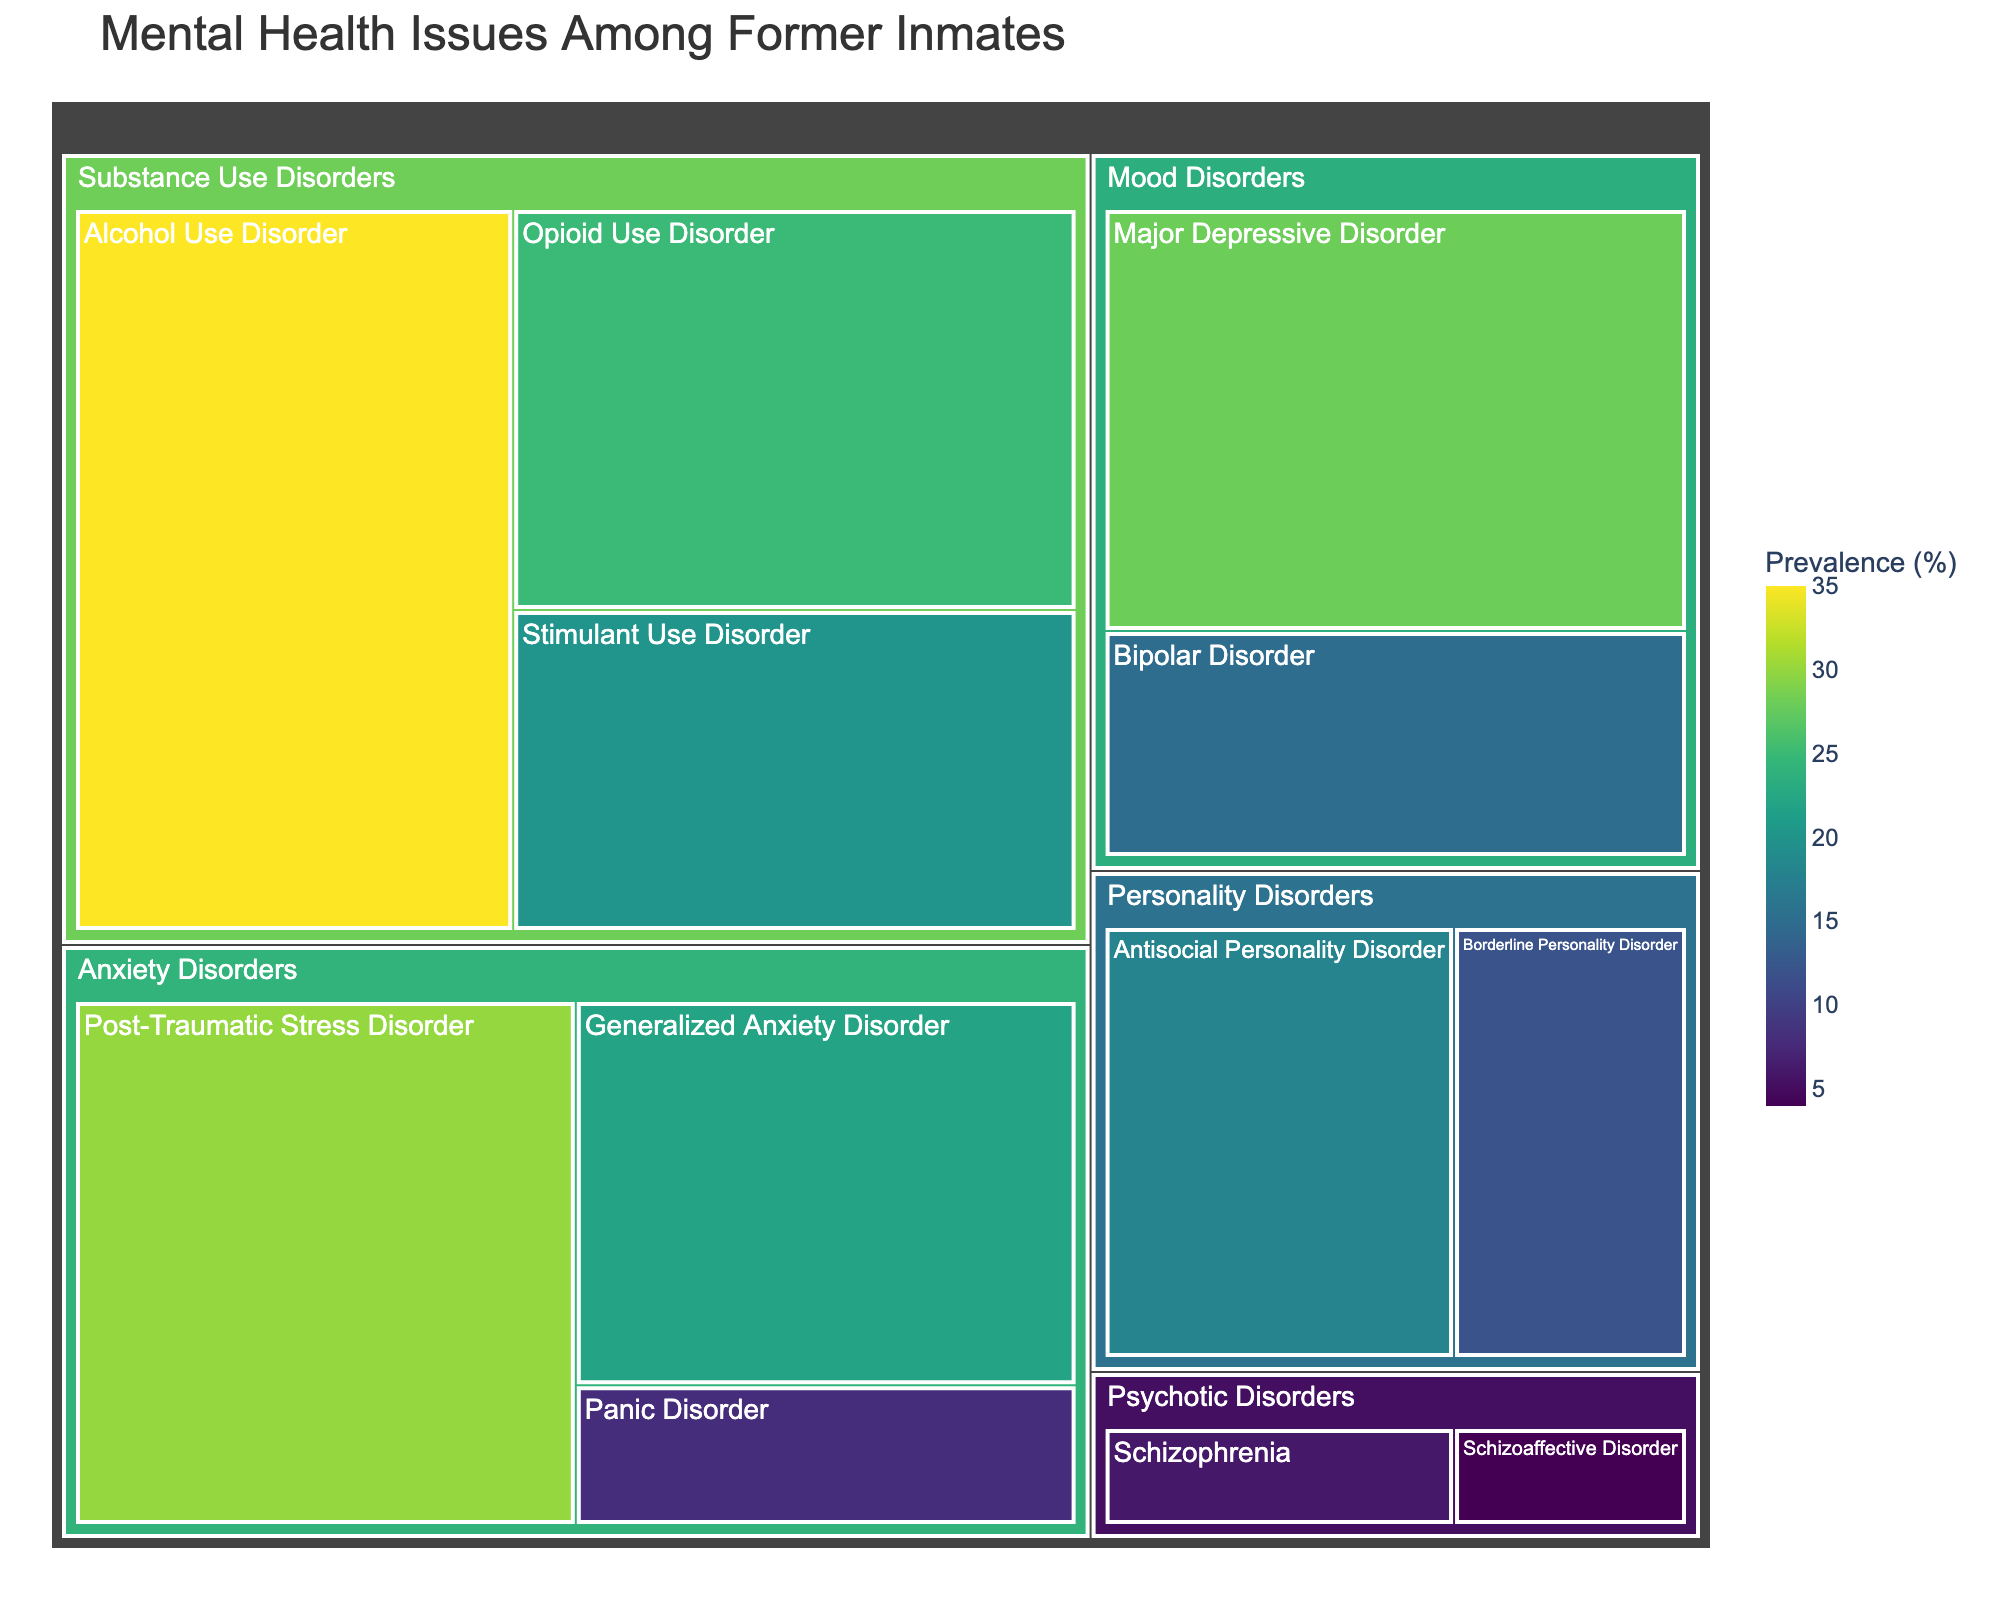What is the title of the treemap? The title is displayed at the top of the treemap, making it easy to identify the main subject of the visualization.
Answer: Mental Health Issues Among Former Inmates Which category has the highest prevalence of a single diagnosis? By looking at the size of the tiles within each category, it is clear that the category with the largest individual tile represents the highest prevalence. The largest tile is for "Alcohol Use Disorder" under "Substance Use Disorders" with 35%.
Answer: Substance Use Disorders What is the combined prevalence of personality disorders? The combined prevalence is found by adding the prevalence percentages for Antisocial Personality Disorder (18) and Borderline Personality Disorder (12). 18 + 12 = 30.
Answer: 30% Which diagnosis within Mood Disorders has a higher prevalence? Comparing the sizes of the tiles within the Mood Disorders category shows that Major Depressive Disorder (28) is larger than Bipolar Disorder (15).
Answer: Major Depressive Disorder What color is used to represent the highest prevalence in the treemap? The color scale used goes from light to dark, with the darkest color representing the highest prevalence. This can be observed as the darkest tile corresponds to Alcohol Use Disorder with 35% prevalence.
Answer: Dark green How does the prevalence of Generalized Anxiety Disorder compare to Panic Disorder? By looking at the sizes of the respective tiles, Generalized Anxiety Disorder has a prevalence of 22%, and Panic Disorder has a prevalence of 8%. Therefore, Generalized Anxiety Disorder is more prevalent.
Answer: Generalized Anxiety Disorder is more prevalent What is the total prevalence for Substance Use Disorders? To find the total prevalence for Substance Use Disorders, sum up the prevalence of Alcohol Use Disorder (35), Opioid Use Disorder (25), and Stimulant Use Disorder (20): 35 + 25 + 20 = 80.
Answer: 80% Which diagnosis under Anxiety Disorders has the highest prevalence? By examining the sizes of the tiles under the Anxiety Disorders category, Post-Traumatic Stress Disorder has the largest tile with a prevalence of 30%.
Answer: Post-Traumatic Stress Disorder Compare the prevalence of Schizophrenia and Schizoaffective Disorder under Psychotic Disorders. By examining the tile sizes, Schizophrenia has a prevalence of 6%, and Schizoaffective Disorder has a prevalence of 4%. Therefore, Schizophrenia is more prevalent.
Answer: Schizophrenia is more prevalent What is the average prevalence of diagnoses under Anxiety Disorders? To find the average prevalence, sum up the prevalence of Generalized Anxiety Disorder (22), Post-Traumatic Stress Disorder (30), and Panic Disorder (8), and then divide by the number of diagnoses: (22 + 30 + 8) / 3 = 20.
Answer: 20 